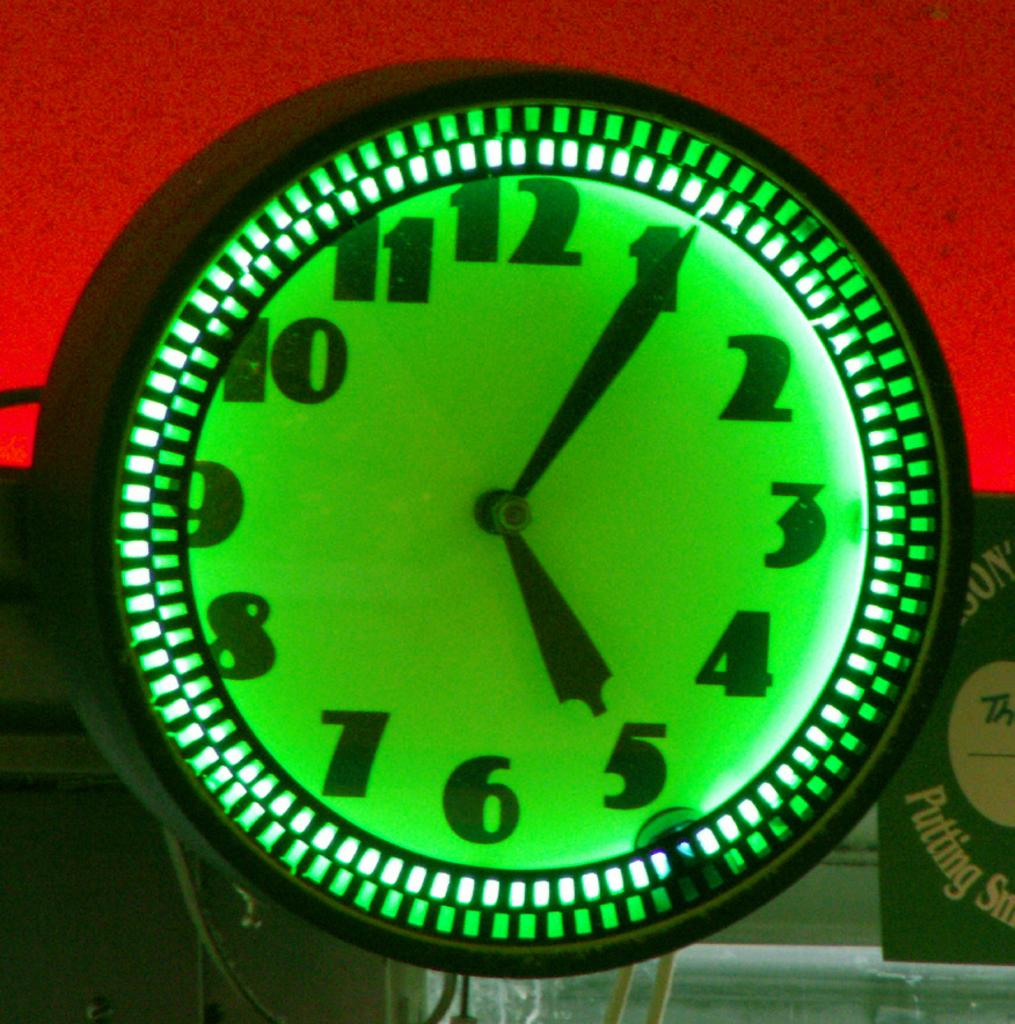<image>
Relay a brief, clear account of the picture shown. A sign behind a clock contains the word Putting. 